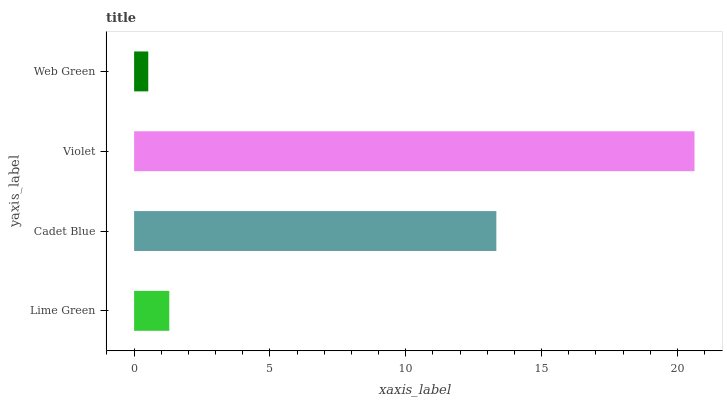Is Web Green the minimum?
Answer yes or no. Yes. Is Violet the maximum?
Answer yes or no. Yes. Is Cadet Blue the minimum?
Answer yes or no. No. Is Cadet Blue the maximum?
Answer yes or no. No. Is Cadet Blue greater than Lime Green?
Answer yes or no. Yes. Is Lime Green less than Cadet Blue?
Answer yes or no. Yes. Is Lime Green greater than Cadet Blue?
Answer yes or no. No. Is Cadet Blue less than Lime Green?
Answer yes or no. No. Is Cadet Blue the high median?
Answer yes or no. Yes. Is Lime Green the low median?
Answer yes or no. Yes. Is Violet the high median?
Answer yes or no. No. Is Web Green the low median?
Answer yes or no. No. 